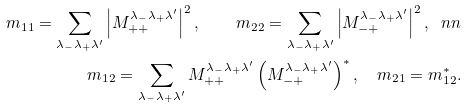<formula> <loc_0><loc_0><loc_500><loc_500>m _ { 1 1 } = \sum _ { \lambda _ { - } \lambda _ { + } \lambda ^ { \prime } } \left | M ^ { \lambda _ { - } \lambda _ { + } \lambda ^ { \prime } } _ { + + } \right | ^ { 2 } , \quad m _ { 2 2 } = \sum _ { \lambda _ { - } \lambda _ { + } \lambda ^ { \prime } } \left | M ^ { \lambda _ { - } \lambda _ { + } \lambda ^ { \prime } } _ { - + } \right | ^ { 2 } , \ n n \\ m _ { 1 2 } = \sum _ { \lambda _ { - } \lambda _ { + } \lambda ^ { \prime } } M ^ { \lambda _ { - } \lambda _ { + } \lambda ^ { \prime } } _ { + + } \left ( M ^ { \lambda _ { - } \lambda _ { + } \lambda ^ { \prime } } _ { - + } \right ) ^ { * } , \quad m _ { 2 1 } = m _ { 1 2 } ^ { * } .</formula> 